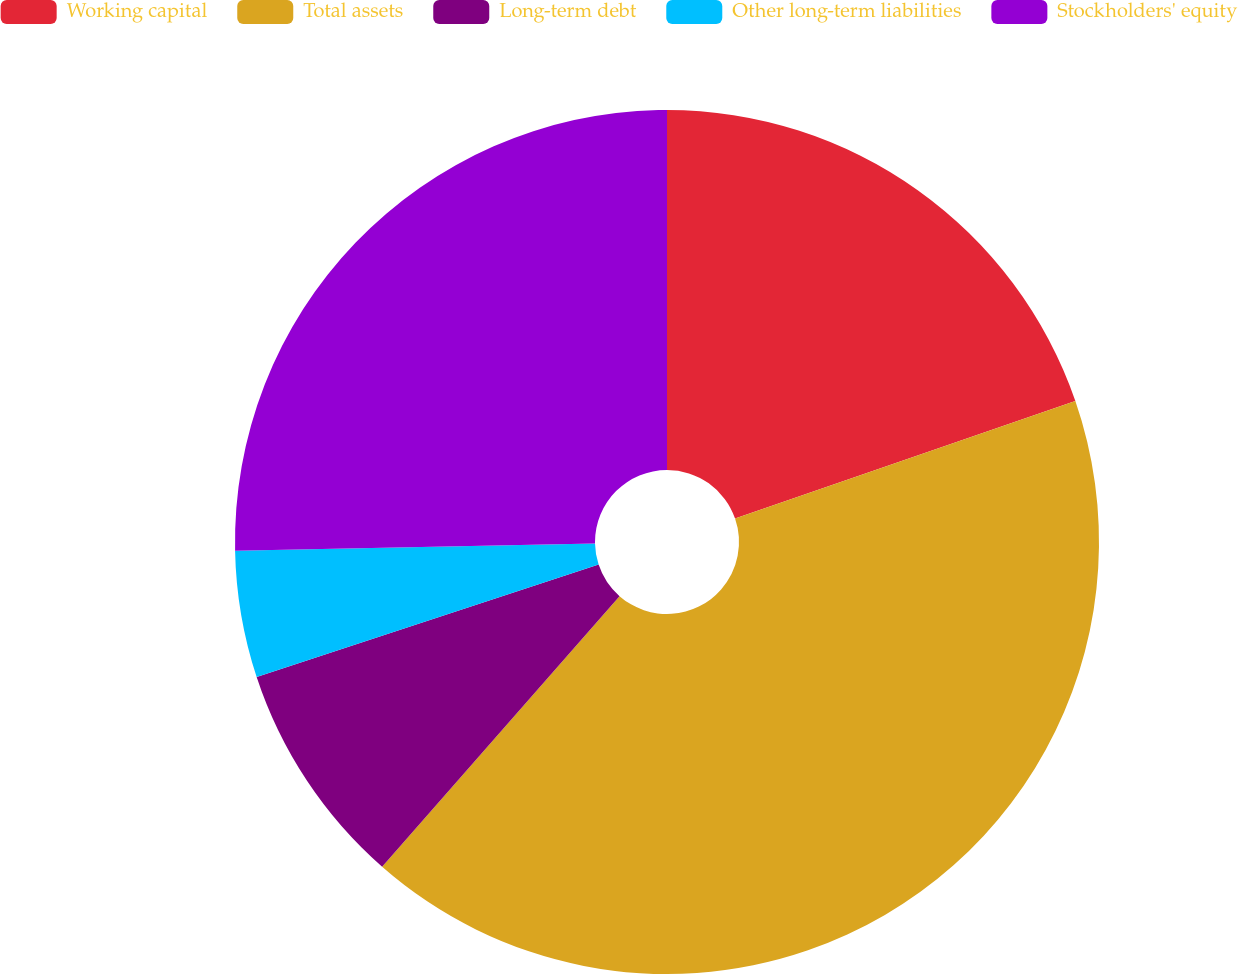Convert chart to OTSL. <chart><loc_0><loc_0><loc_500><loc_500><pie_chart><fcel>Working capital<fcel>Total assets<fcel>Long-term debt<fcel>Other long-term liabilities<fcel>Stockholders' equity<nl><fcel>19.71%<fcel>41.75%<fcel>8.48%<fcel>4.74%<fcel>25.32%<nl></chart> 